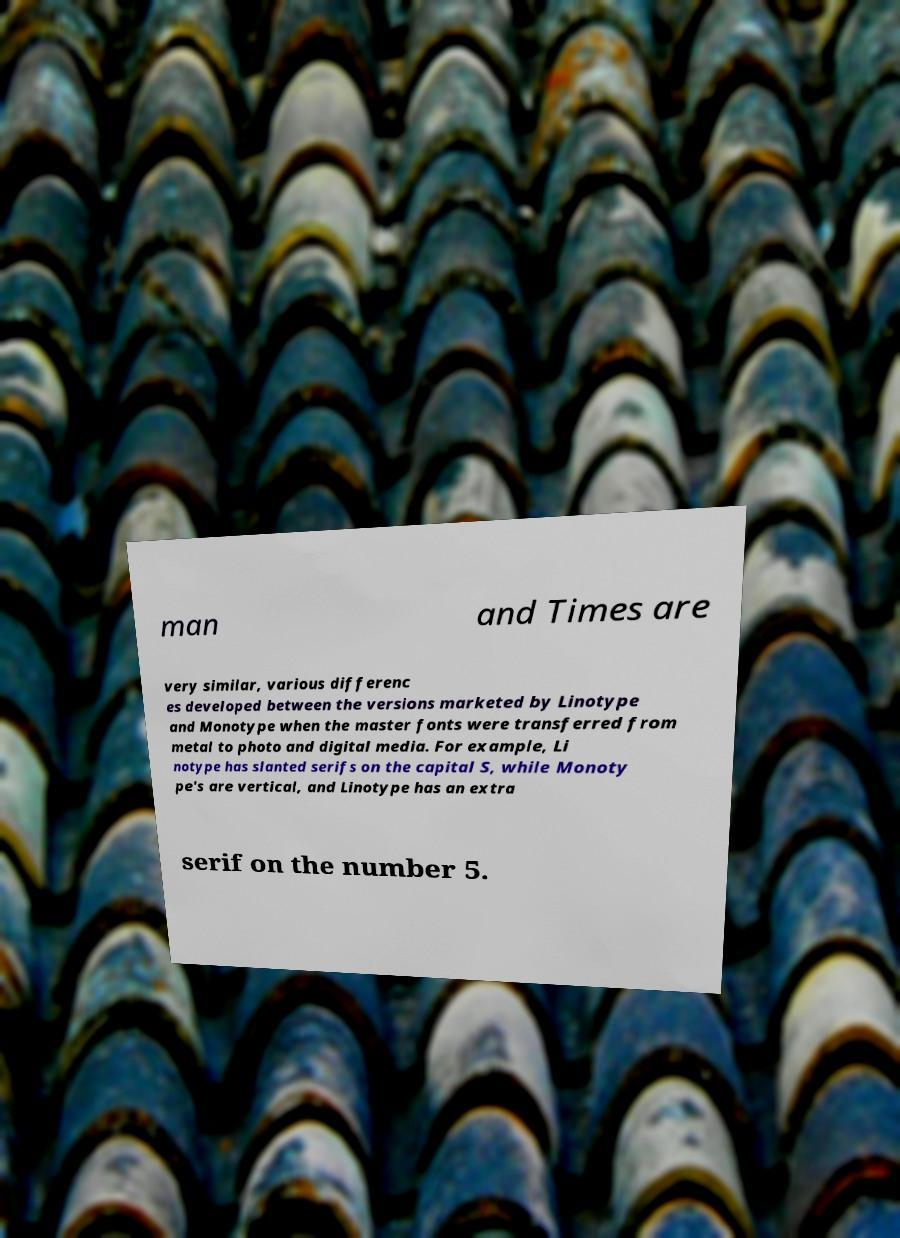Can you read and provide the text displayed in the image?This photo seems to have some interesting text. Can you extract and type it out for me? man and Times are very similar, various differenc es developed between the versions marketed by Linotype and Monotype when the master fonts were transferred from metal to photo and digital media. For example, Li notype has slanted serifs on the capital S, while Monoty pe's are vertical, and Linotype has an extra serif on the number 5. 